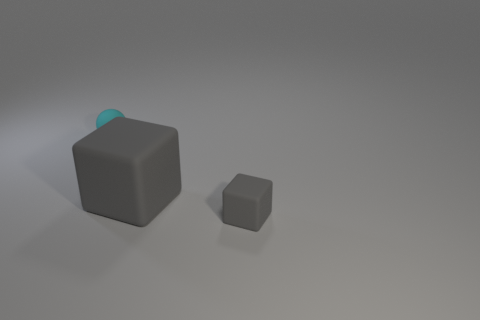Subtract all blue spheres. Subtract all purple cylinders. How many spheres are left? 1 Add 3 small rubber balls. How many objects exist? 6 Subtract all blocks. How many objects are left? 1 Subtract all tiny green metallic cylinders. Subtract all cyan rubber balls. How many objects are left? 2 Add 3 balls. How many balls are left? 4 Add 1 big cubes. How many big cubes exist? 2 Subtract 0 blue cylinders. How many objects are left? 3 